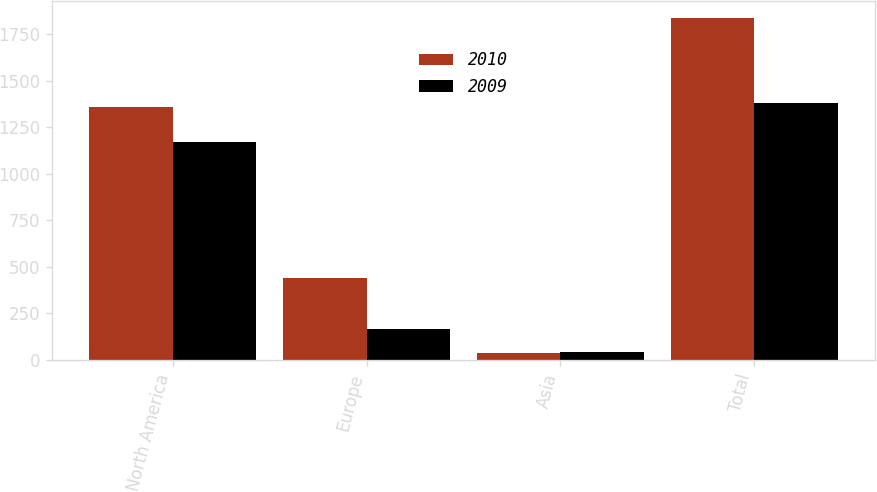Convert chart to OTSL. <chart><loc_0><loc_0><loc_500><loc_500><stacked_bar_chart><ecel><fcel>North America<fcel>Europe<fcel>Asia<fcel>Total<nl><fcel>2010<fcel>1357<fcel>440<fcel>37<fcel>1834<nl><fcel>2009<fcel>1171<fcel>169<fcel>42<fcel>1382<nl></chart> 